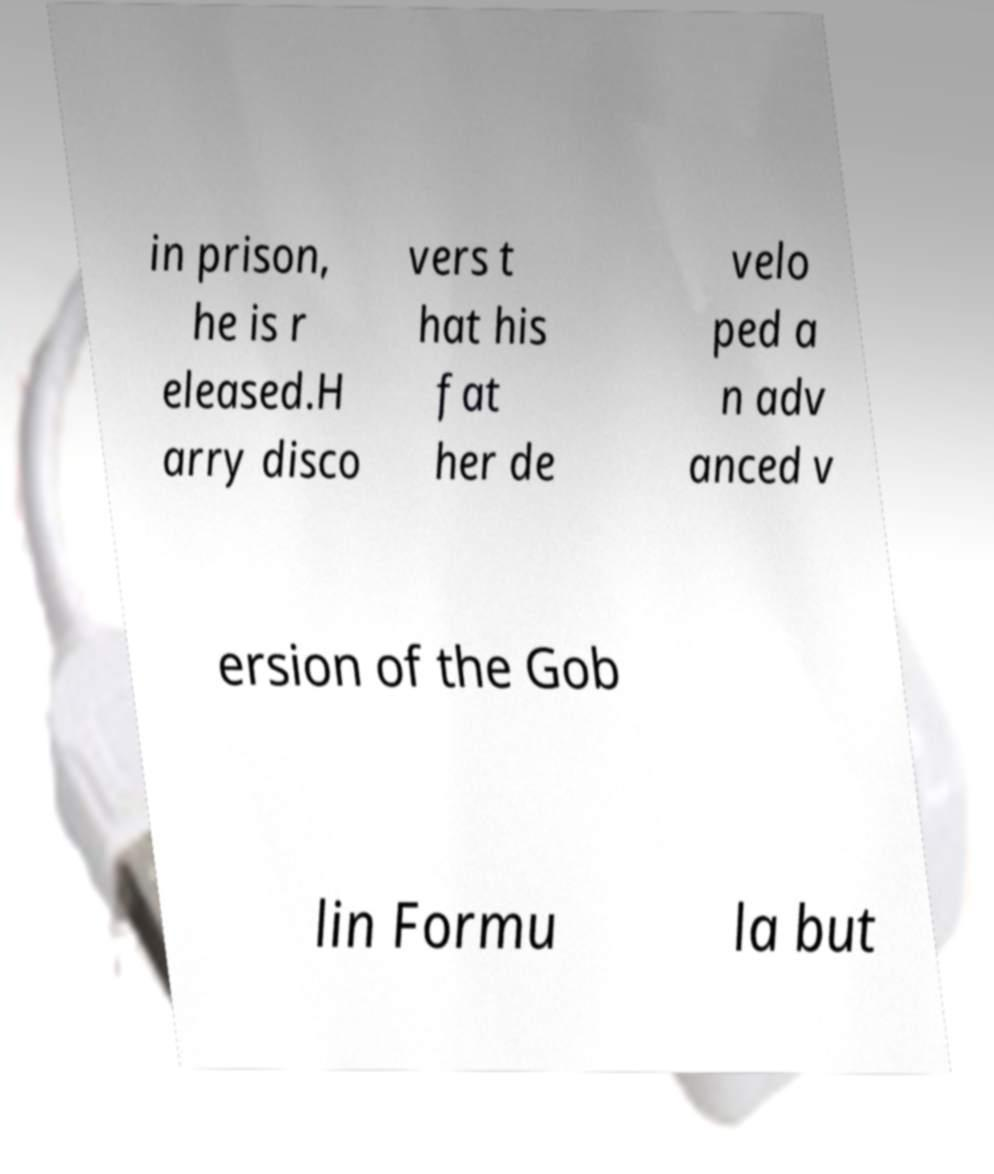Please identify and transcribe the text found in this image. in prison, he is r eleased.H arry disco vers t hat his fat her de velo ped a n adv anced v ersion of the Gob lin Formu la but 